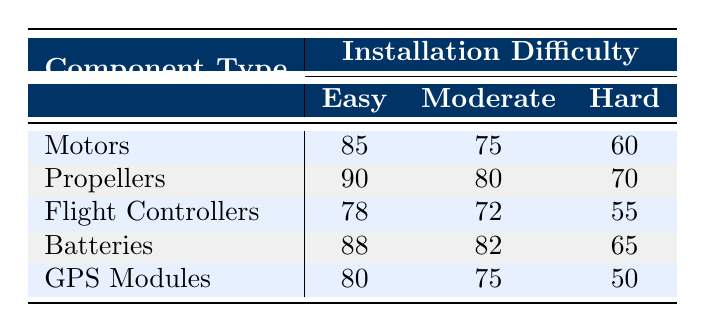What is the customer satisfaction rating for Motors with Easy installation difficulty? The table shows that for Motors with Easy installation difficulty, the customer satisfaction rating is listed directly as 85.
Answer: 85 What is the difference in customer satisfaction between Batteries with Easy and Hard installation difficulties? For Batteries, the customer satisfaction rating is 88 for Easy and 65 for Hard. The difference is 88 - 65 = 23.
Answer: 23 Is the customer satisfaction for Flight Controllers with Moderate installation difficulty greater than 70? The customer satisfaction rating for Flight Controllers with Moderate installation difficulty is 72, which is indeed greater than 70.
Answer: Yes What is the average customer satisfaction rating for Propellers across all installation difficulties? The ratings for Propellers across Easy (90), Moderate (80), and Hard (70) are summed: 90 + 80 + 70 = 240. There are 3 ratings, so the average is 240 / 3 = 80.
Answer: 80 Which component type has the highest customer satisfaction rating for Hard installation difficulty? Looking at the Hard installation difficulty ratings: Motors (60), Propellers (70), Flight Controllers (55), Batteries (65), and GPS Modules (50), the highest rating is for Propellers with 70.
Answer: Propellers 